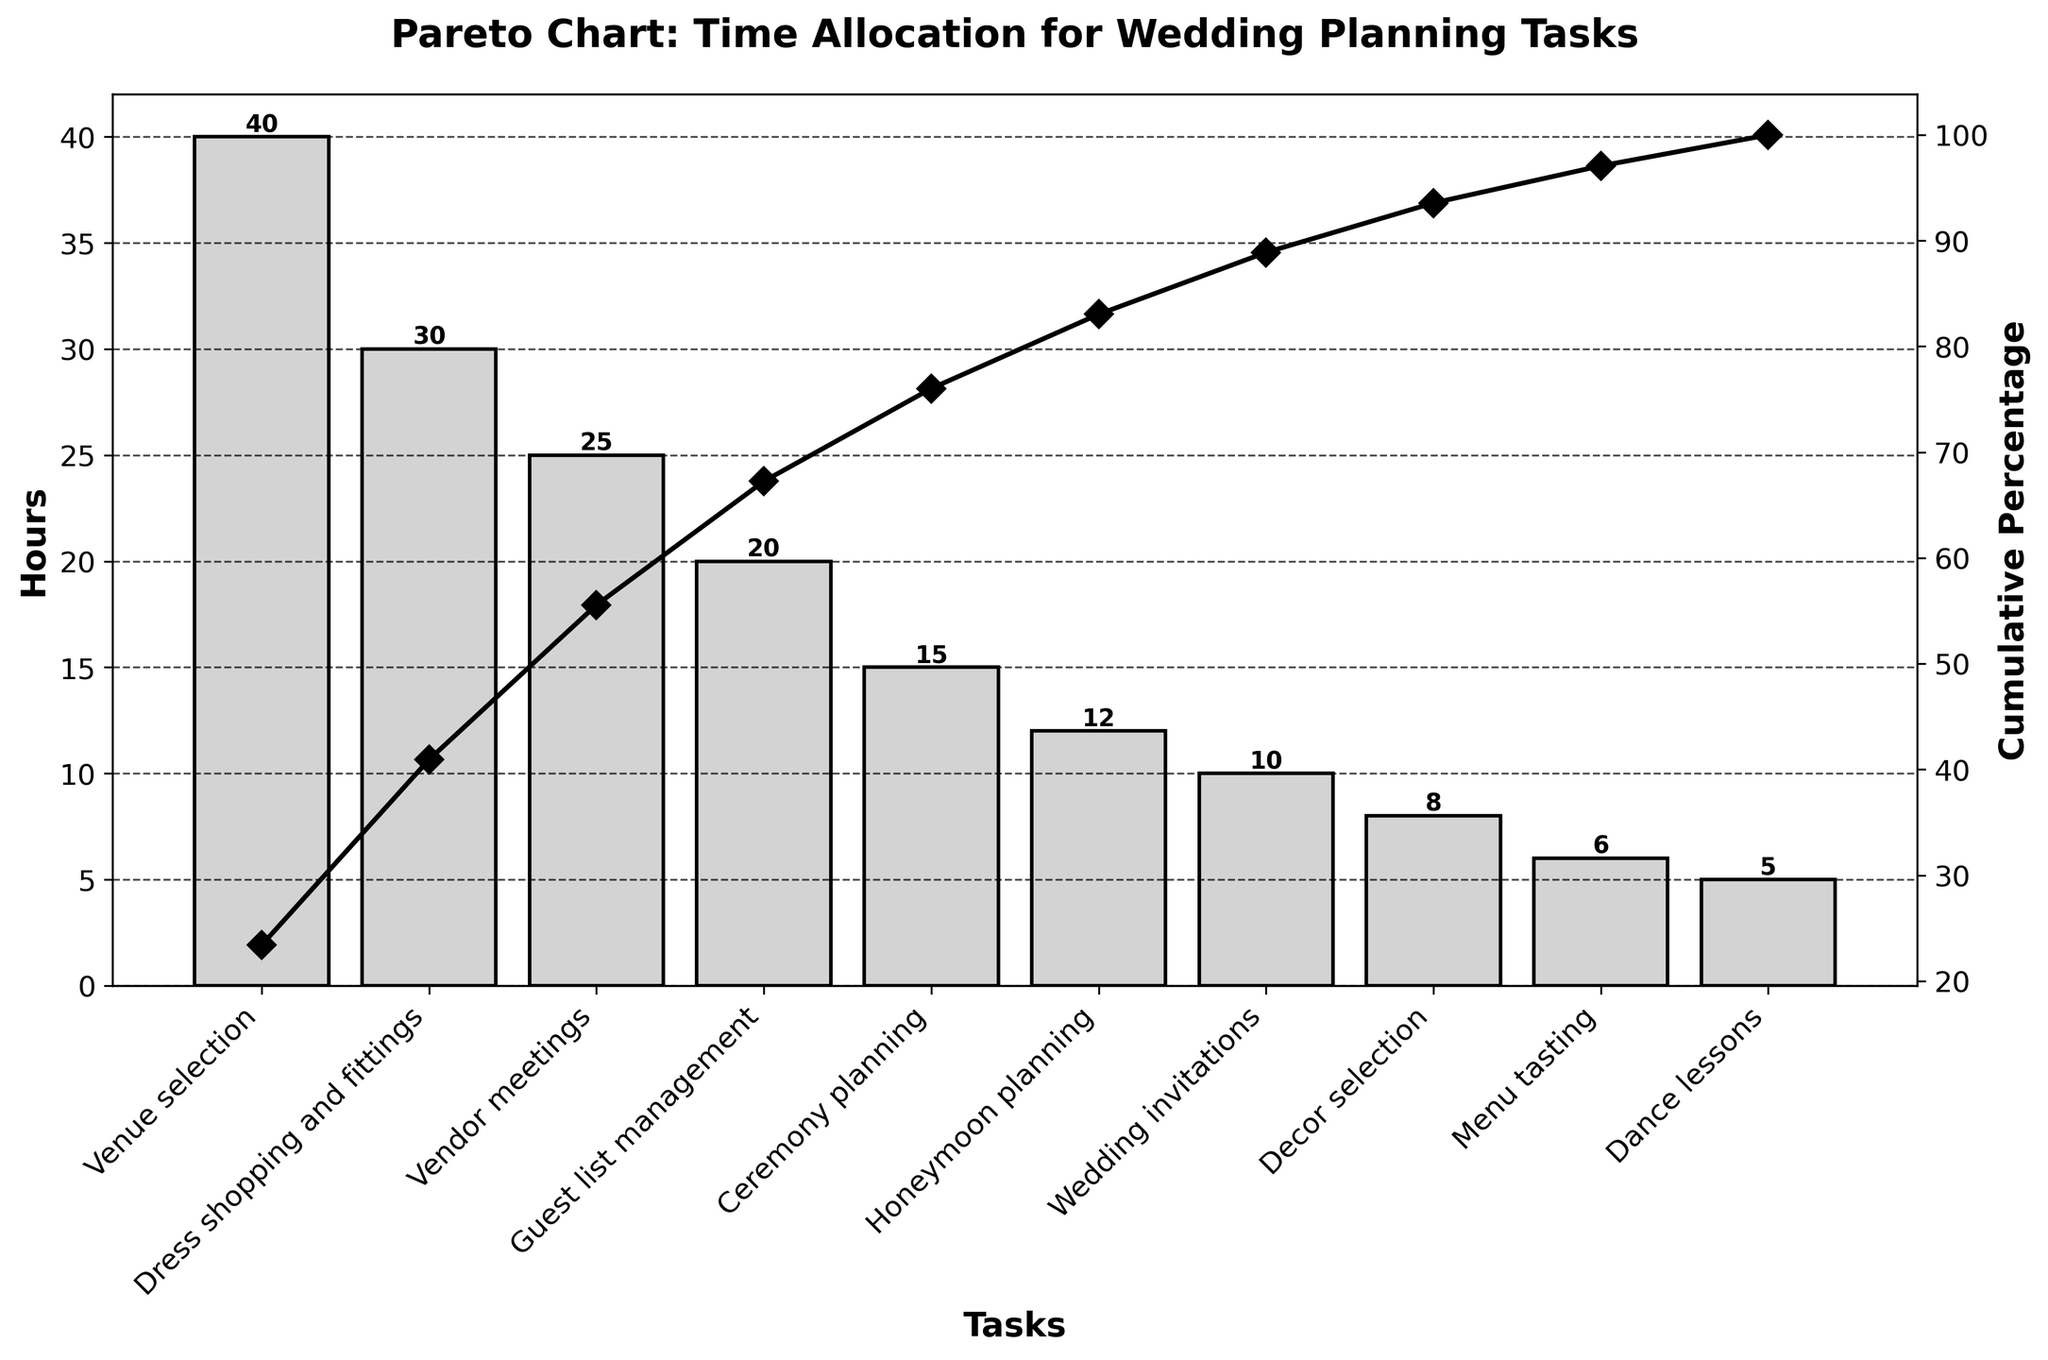What's the title of the chart? The title is located at the top of the figure, and it notes what the chart represents.
Answer: Pareto Chart: Time Allocation for Wedding Planning Tasks How many tasks are listed in the chart? The chart lists individual tasks on the x-axis for each bar in the bar chart. Counting these gives the total number of tasks.
Answer: 10 Which task took the most hours to complete? The task with the highest bar on the chart represents the one that took the most hours.
Answer: Venue selection What's the cumulative percentage after the third task? Look at the line connecting the markers for the cumulative percentage, and check the value at the third task.
Answer: 68% What is the difference in hours between the task that took the most time and the task that took the least time? Subtract the hours for the task with the smallest bar (Dance lessons) from the hours for the task with the largest bar (Venue selection).
Answer: 35 hours Which tasks collectively make up over 50% of the total planning time? Look at the cumulative percentage line and identify the tasks until the cumulative percentage surpasses 50%.
Answer: Venue selection, Dress shopping and fittings, Vendor meetings How many hours in total were spent on the top two most time-consuming tasks? Add the hours of the two bars with the highest values.
Answer: 70 hours Which task comes immediately before honeymoon planning in terms of hours spent? Look at the position of "Honeymoon planning" on the x-axis and identify the task immediately to its left.
Answer: Ceremony planning How much time was spent on tasks that took less than 10 hours each? Add the hours of tasks with bars that are less than 10 hours long.
Answer: 19 hours What is the cumulative percentage of time after "Ceremony planning" is completed? Examine the cumulative percentage line and find the percentage at the point corresponding to Ceremony planning.
Answer: 86% 